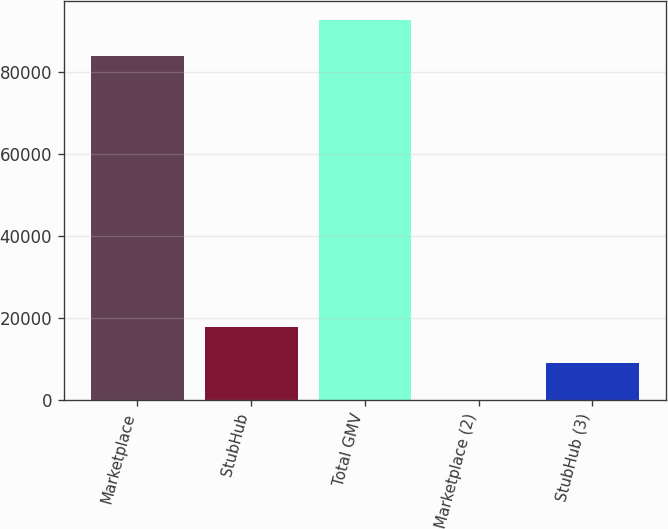<chart> <loc_0><loc_0><loc_500><loc_500><bar_chart><fcel>Marketplace<fcel>StubHub<fcel>Total GMV<fcel>Marketplace (2)<fcel>StubHub (3)<nl><fcel>83883<fcel>17686.8<fcel>92722.5<fcel>7.69<fcel>8847.22<nl></chart> 